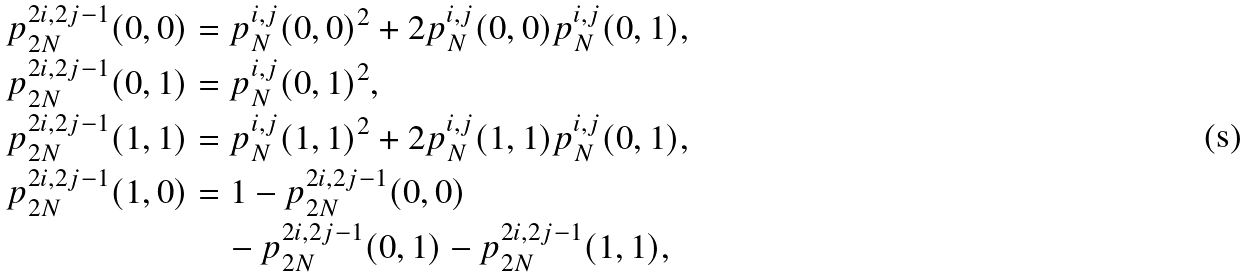<formula> <loc_0><loc_0><loc_500><loc_500>p _ { 2 N } ^ { 2 i , 2 j - 1 } ( 0 , 0 ) & = p _ { N } ^ { i , j } ( 0 , 0 ) ^ { 2 } + 2 p _ { N } ^ { i , j } ( 0 , 0 ) p _ { N } ^ { i , j } ( 0 , 1 ) \text {,} \\ p _ { 2 N } ^ { 2 i , 2 j - 1 } ( 0 , 1 ) & = p _ { N } ^ { i , j } ( 0 , 1 ) ^ { 2 } \text {,} \\ p _ { 2 N } ^ { 2 i , 2 j - 1 } ( 1 , 1 ) & = p _ { N } ^ { i , j } ( 1 , 1 ) ^ { 2 } + 2 p _ { N } ^ { i , j } ( 1 , 1 ) p _ { N } ^ { i , j } ( 0 , 1 ) \text {,} \\ p _ { 2 N } ^ { 2 i , 2 j - 1 } ( 1 , 0 ) & = 1 - p _ { 2 N } ^ { 2 i , 2 j - 1 } ( 0 , 0 ) \\ & \quad - p _ { 2 N } ^ { 2 i , 2 j - 1 } ( 0 , 1 ) - p _ { 2 N } ^ { 2 i , 2 j - 1 } ( 1 , 1 ) \text {,}</formula> 